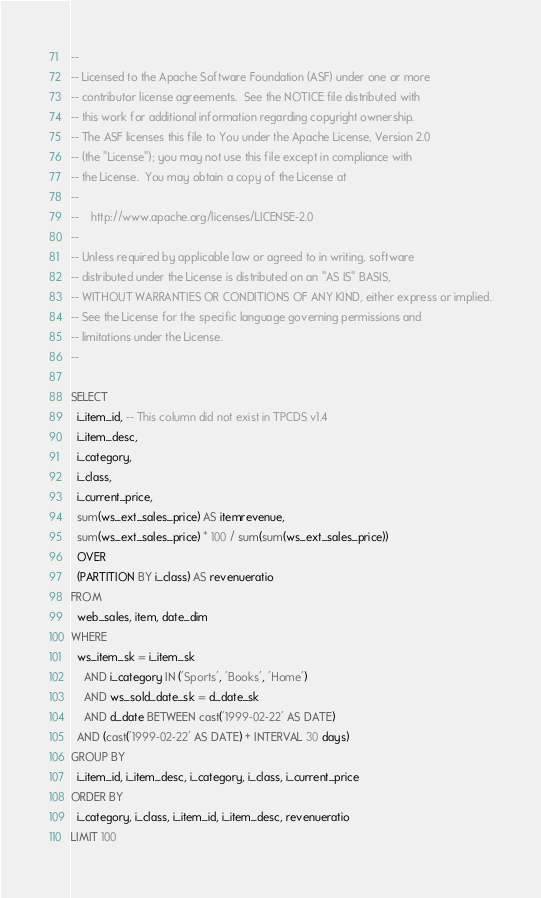<code> <loc_0><loc_0><loc_500><loc_500><_SQL_>--
-- Licensed to the Apache Software Foundation (ASF) under one or more
-- contributor license agreements.  See the NOTICE file distributed with
-- this work for additional information regarding copyright ownership.
-- The ASF licenses this file to You under the Apache License, Version 2.0
-- (the "License"); you may not use this file except in compliance with
-- the License.  You may obtain a copy of the License at
--
--    http://www.apache.org/licenses/LICENSE-2.0
--
-- Unless required by applicable law or agreed to in writing, software
-- distributed under the License is distributed on an "AS IS" BASIS,
-- WITHOUT WARRANTIES OR CONDITIONS OF ANY KIND, either express or implied.
-- See the License for the specific language governing permissions and
-- limitations under the License.
--

SELECT
  i_item_id, -- This column did not exist in TPCDS v1.4
  i_item_desc,
  i_category,
  i_class,
  i_current_price,
  sum(ws_ext_sales_price) AS itemrevenue,
  sum(ws_ext_sales_price) * 100 / sum(sum(ws_ext_sales_price))
  OVER
  (PARTITION BY i_class) AS revenueratio
FROM
  web_sales, item, date_dim
WHERE
  ws_item_sk = i_item_sk
    AND i_category IN ('Sports', 'Books', 'Home')
    AND ws_sold_date_sk = d_date_sk
    AND d_date BETWEEN cast('1999-02-22' AS DATE)
  AND (cast('1999-02-22' AS DATE) + INTERVAL 30 days)
GROUP BY
  i_item_id, i_item_desc, i_category, i_class, i_current_price
ORDER BY
  i_category, i_class, i_item_id, i_item_desc, revenueratio
LIMIT 100
</code> 